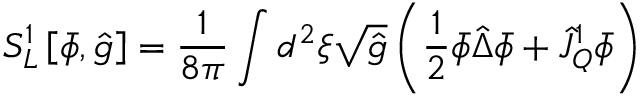<formula> <loc_0><loc_0><loc_500><loc_500>{ S _ { L } ^ { 1 } } \left [ \bar { \phi } , \hat { g } \right ] = { \frac { 1 } { 8 \pi } } \int { d ^ { 2 } } \xi \sqrt { \hat { g } } \left ( { \frac { 1 } { 2 } } \bar { \phi } \hat { \Delta } \bar { \phi } + { \hat { J } _ { Q } ^ { 1 } } \bar { \phi } \right )</formula> 